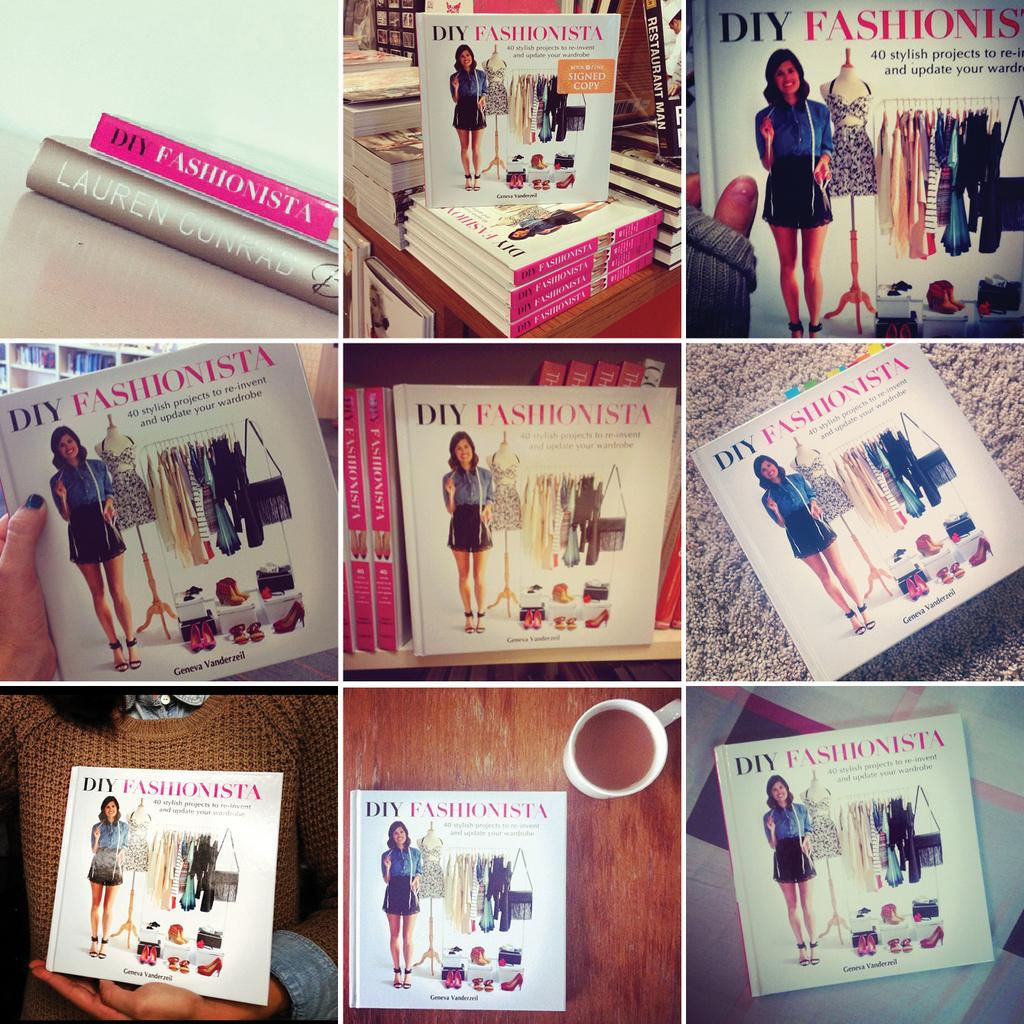<image>
Describe the image concisely. A fashion themed book is seen in 9 different angles. 